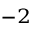<formula> <loc_0><loc_0><loc_500><loc_500>^ { - 2 }</formula> 